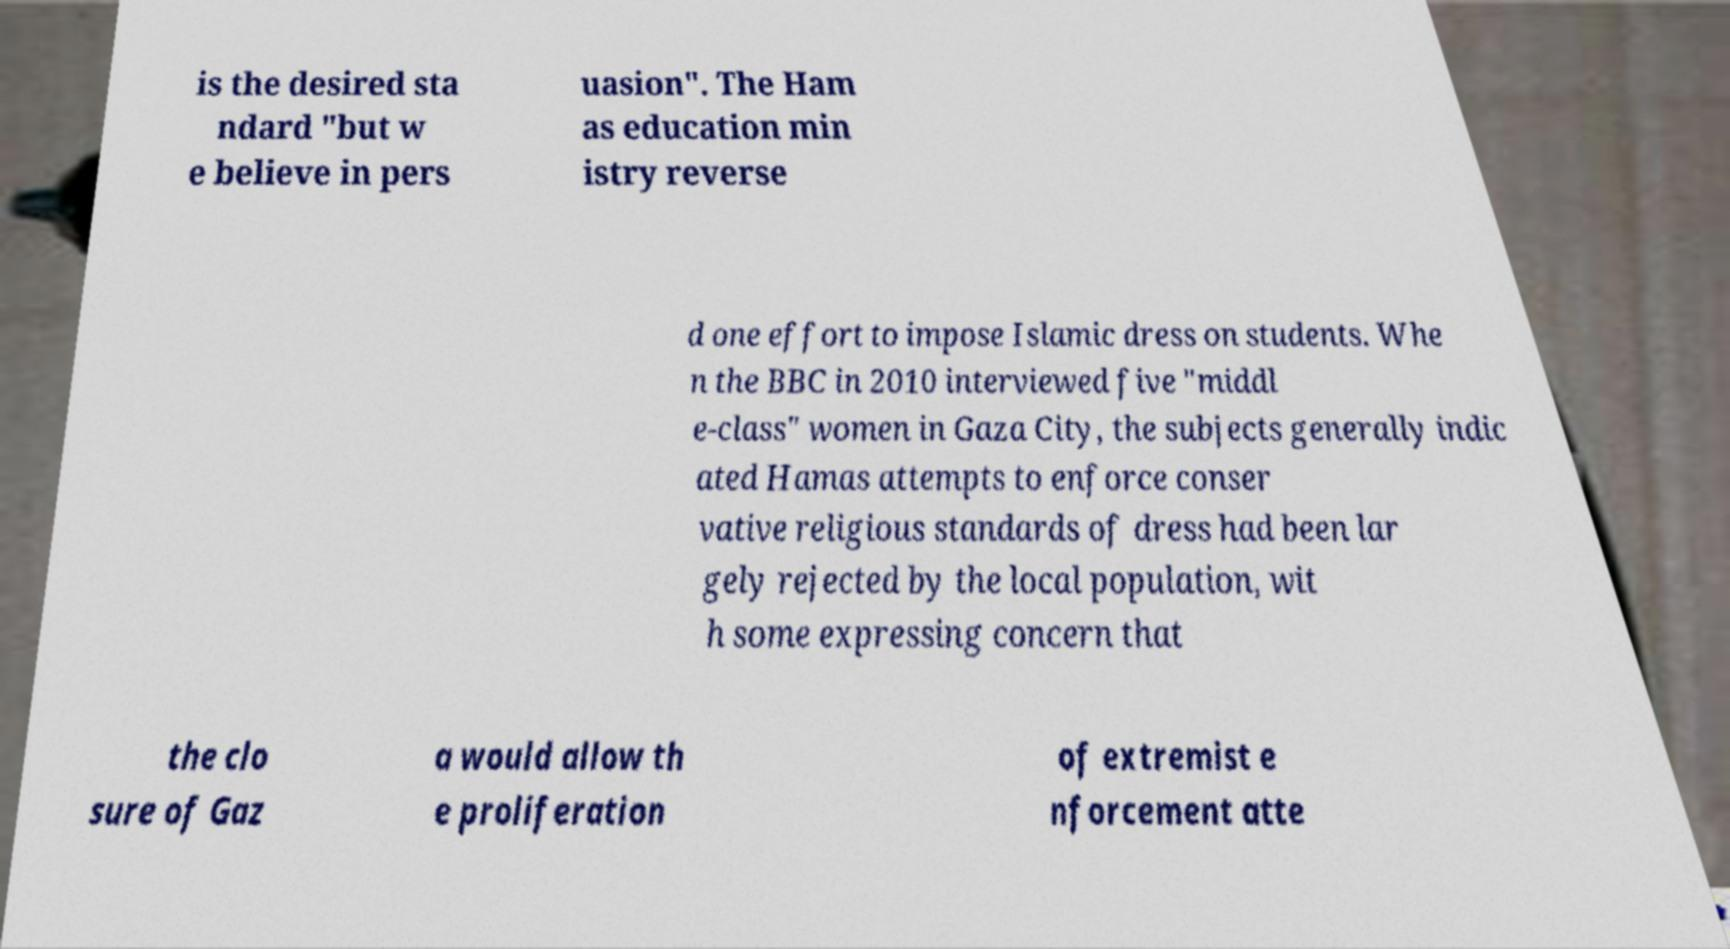I need the written content from this picture converted into text. Can you do that? is the desired sta ndard "but w e believe in pers uasion". The Ham as education min istry reverse d one effort to impose Islamic dress on students. Whe n the BBC in 2010 interviewed five "middl e-class" women in Gaza City, the subjects generally indic ated Hamas attempts to enforce conser vative religious standards of dress had been lar gely rejected by the local population, wit h some expressing concern that the clo sure of Gaz a would allow th e proliferation of extremist e nforcement atte 